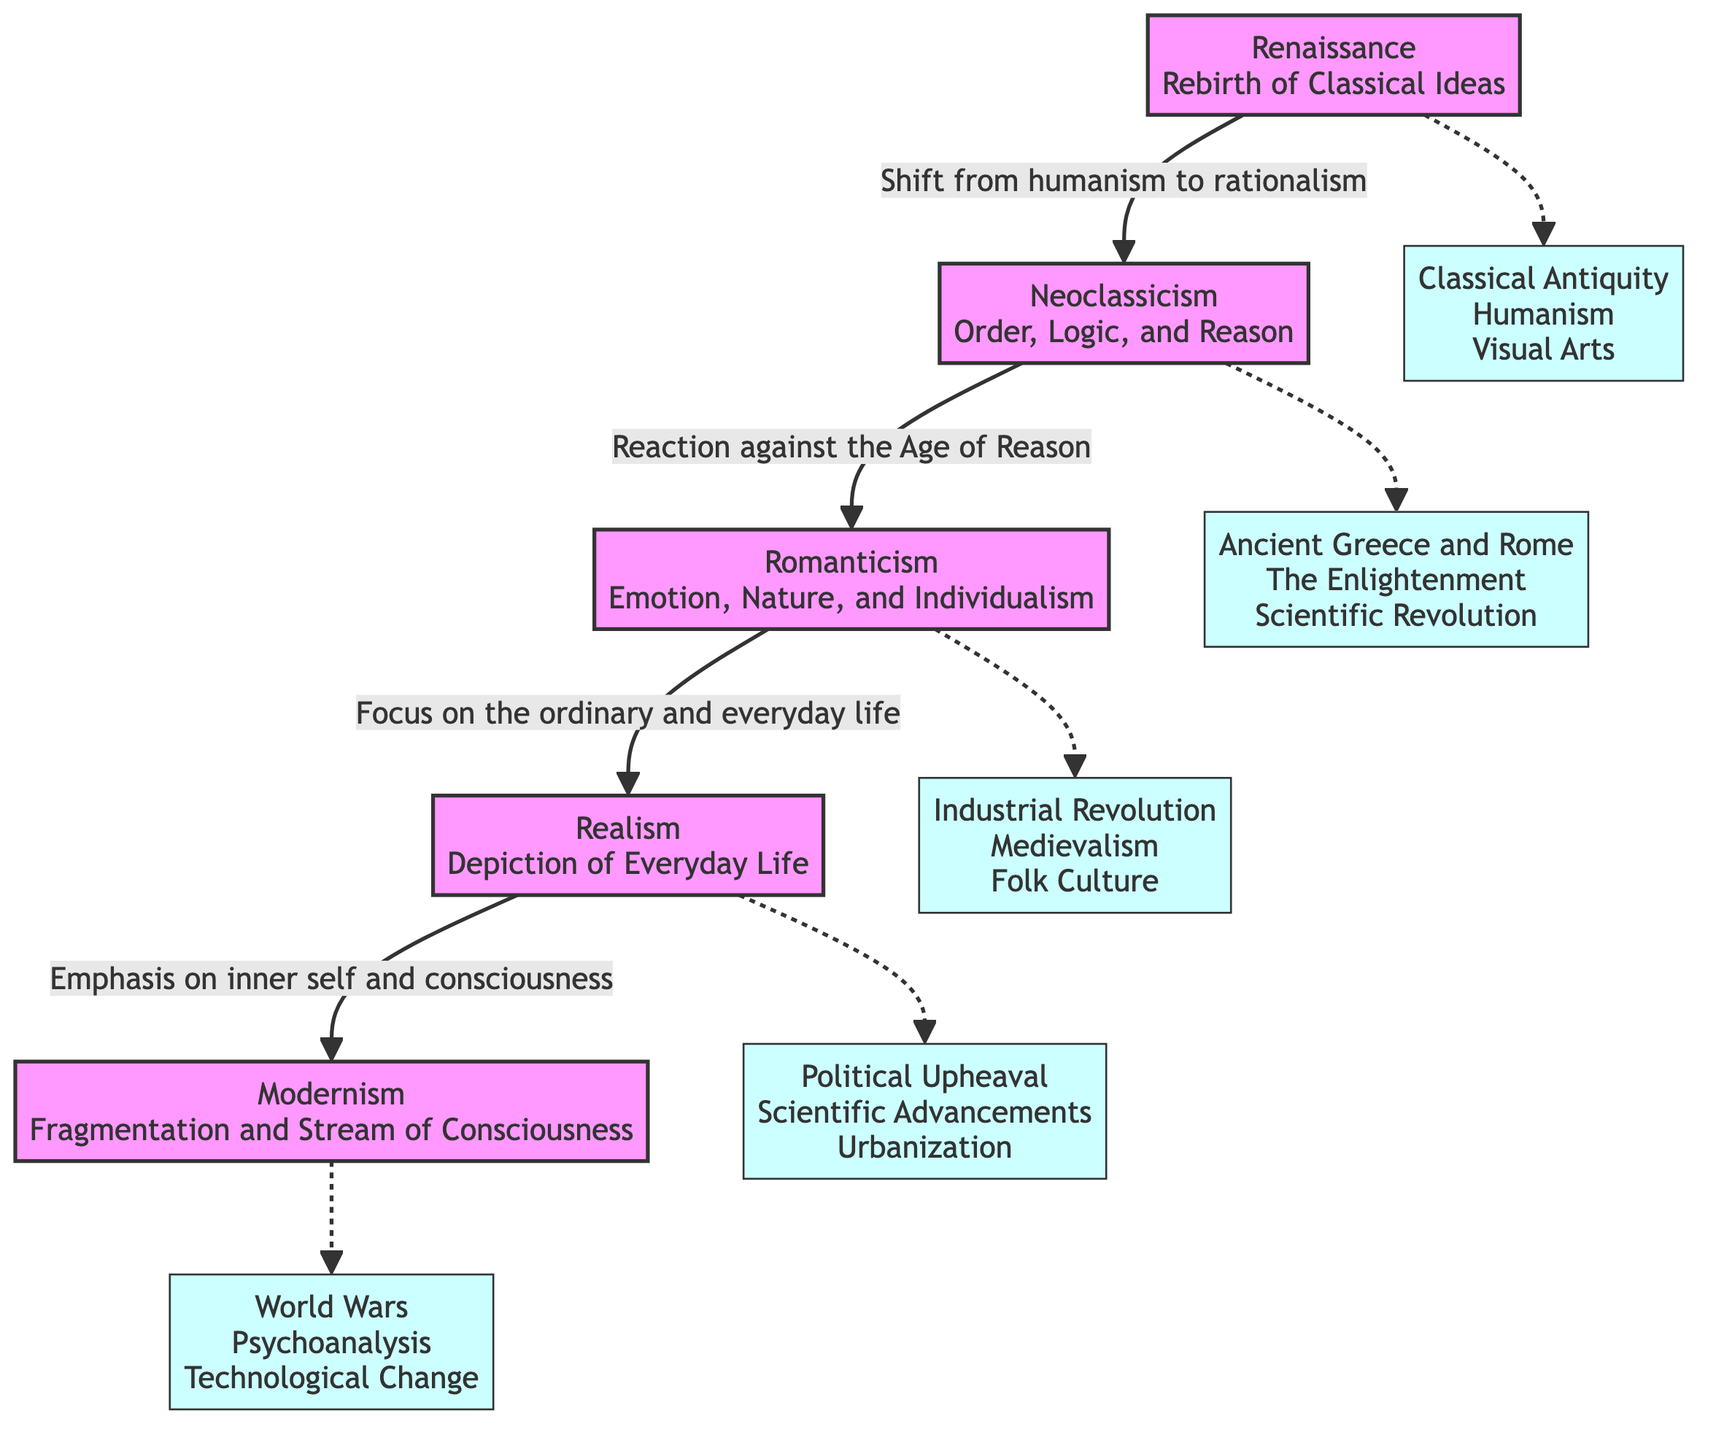What literary movement follows the Renaissance? According to the diagram, the literary movement that follows the Renaissance is Neoclassicism, as indicated by the directed arrow leading from Renaissance to Neoclassicism.
Answer: Neoclassicism Which theme is associated with Modernism? The diagram shows that the theme associated with Modernism is "Fragmentation and Stream of Consciousness." This is directly stated in the description of the Modernism node.
Answer: Fragmentation and Stream of Consciousness What is one influence on Realism? The diagram lists "Political Upheaval" as one of the influences on Realism, shown by the dashed line connecting Realism to its influences node.
Answer: Political Upheaval How many literary movements are depicted in the diagram? By counting the movements represented in the diagram, there are five literary movements from Renaissance to Modernism. These movements are clearly listed as nodes in the diagram.
Answer: Five Which movement is characterized by a focus on ordinary life? The diagram shows that Realism is characterized by a focus on the ordinary and everyday life, highlighting that connection through the labeled relationship leading from Romanticism to Realism.
Answer: Realism What connects Neoclassicism to Romanticism? The diagram indicates a direct relationship between Neoclassicism and Romanticism, stating it as a "Reaction against the Age of Reason," which is the label on the directed arrow connecting the two movements.
Answer: Reaction against the Age of Reason Which influence connects Romanticism to the Industrial Revolution? The dashed line from Romanticism to its influence node indicates "Industrial Revolution" as one of the key influences, revealing its connection within the context of the diagram.
Answer: Industrial Revolution What represents the transition from Realism to Modernism? The diagram explicitly states that the transition from Realism to Modernism is emphasized by "Emphasis on inner self and consciousness," which is the labeled arrow between these two movements.
Answer: Emphasis on inner self and consciousness Which two movements share a common influence in their development? The diagram shows that Romanticism and Realism both share influences from the societal conditions of their times, specifically "Folk Culture" for Romanticism and "Political Upheaval" for Realism, indicating shared thematic concerns in response to societal changes.
Answer: Folk Culture and Political Upheaval 